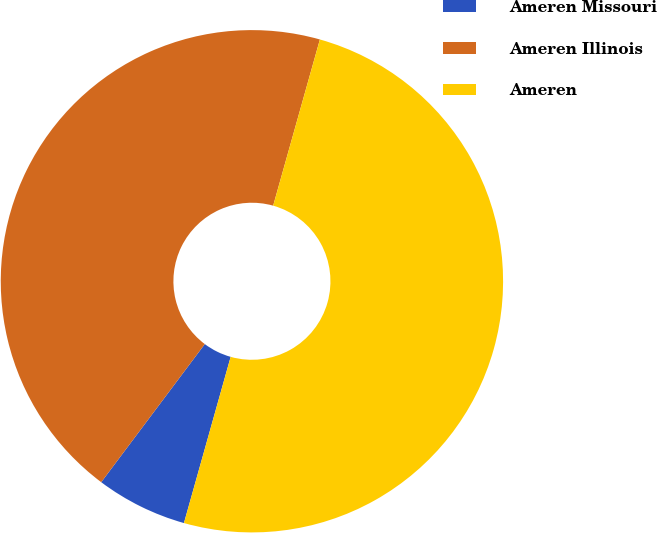<chart> <loc_0><loc_0><loc_500><loc_500><pie_chart><fcel>Ameren Missouri<fcel>Ameren Illinois<fcel>Ameren<nl><fcel>5.88%<fcel>44.12%<fcel>50.0%<nl></chart> 